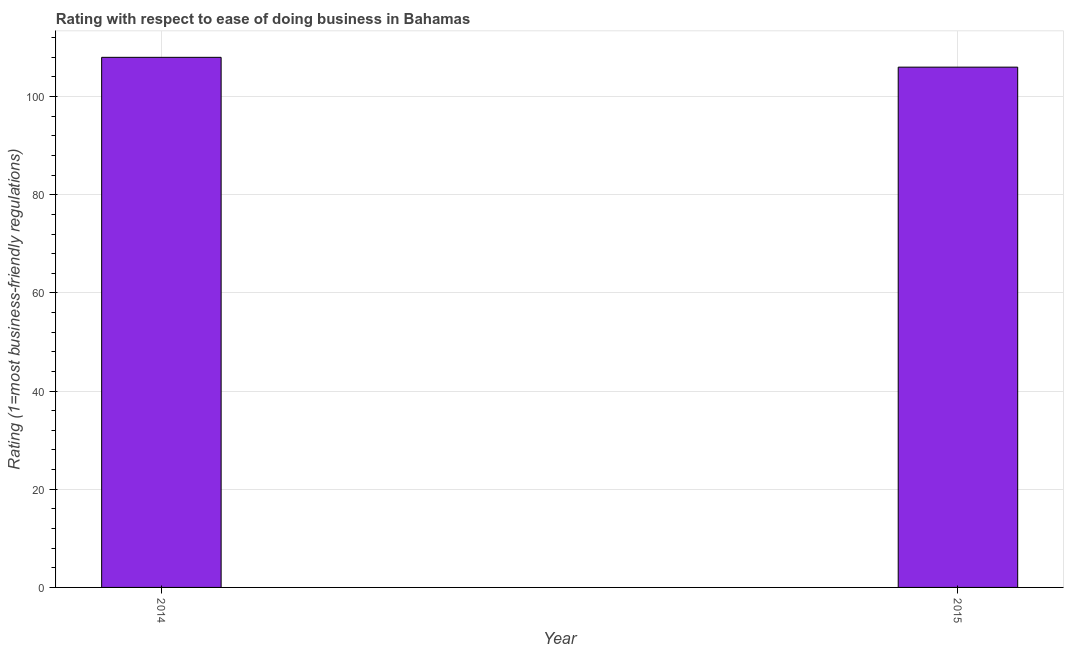Does the graph contain any zero values?
Your answer should be compact. No. What is the title of the graph?
Keep it short and to the point. Rating with respect to ease of doing business in Bahamas. What is the label or title of the Y-axis?
Ensure brevity in your answer.  Rating (1=most business-friendly regulations). What is the ease of doing business index in 2015?
Keep it short and to the point. 106. Across all years, what is the maximum ease of doing business index?
Ensure brevity in your answer.  108. Across all years, what is the minimum ease of doing business index?
Provide a short and direct response. 106. In which year was the ease of doing business index maximum?
Your answer should be very brief. 2014. In which year was the ease of doing business index minimum?
Your answer should be very brief. 2015. What is the sum of the ease of doing business index?
Offer a terse response. 214. What is the difference between the ease of doing business index in 2014 and 2015?
Your answer should be very brief. 2. What is the average ease of doing business index per year?
Offer a terse response. 107. What is the median ease of doing business index?
Your answer should be very brief. 107. In how many years, is the ease of doing business index greater than 8 ?
Ensure brevity in your answer.  2. What is the Rating (1=most business-friendly regulations) in 2014?
Offer a very short reply. 108. What is the Rating (1=most business-friendly regulations) of 2015?
Make the answer very short. 106. What is the difference between the Rating (1=most business-friendly regulations) in 2014 and 2015?
Provide a succinct answer. 2. What is the ratio of the Rating (1=most business-friendly regulations) in 2014 to that in 2015?
Offer a very short reply. 1.02. 